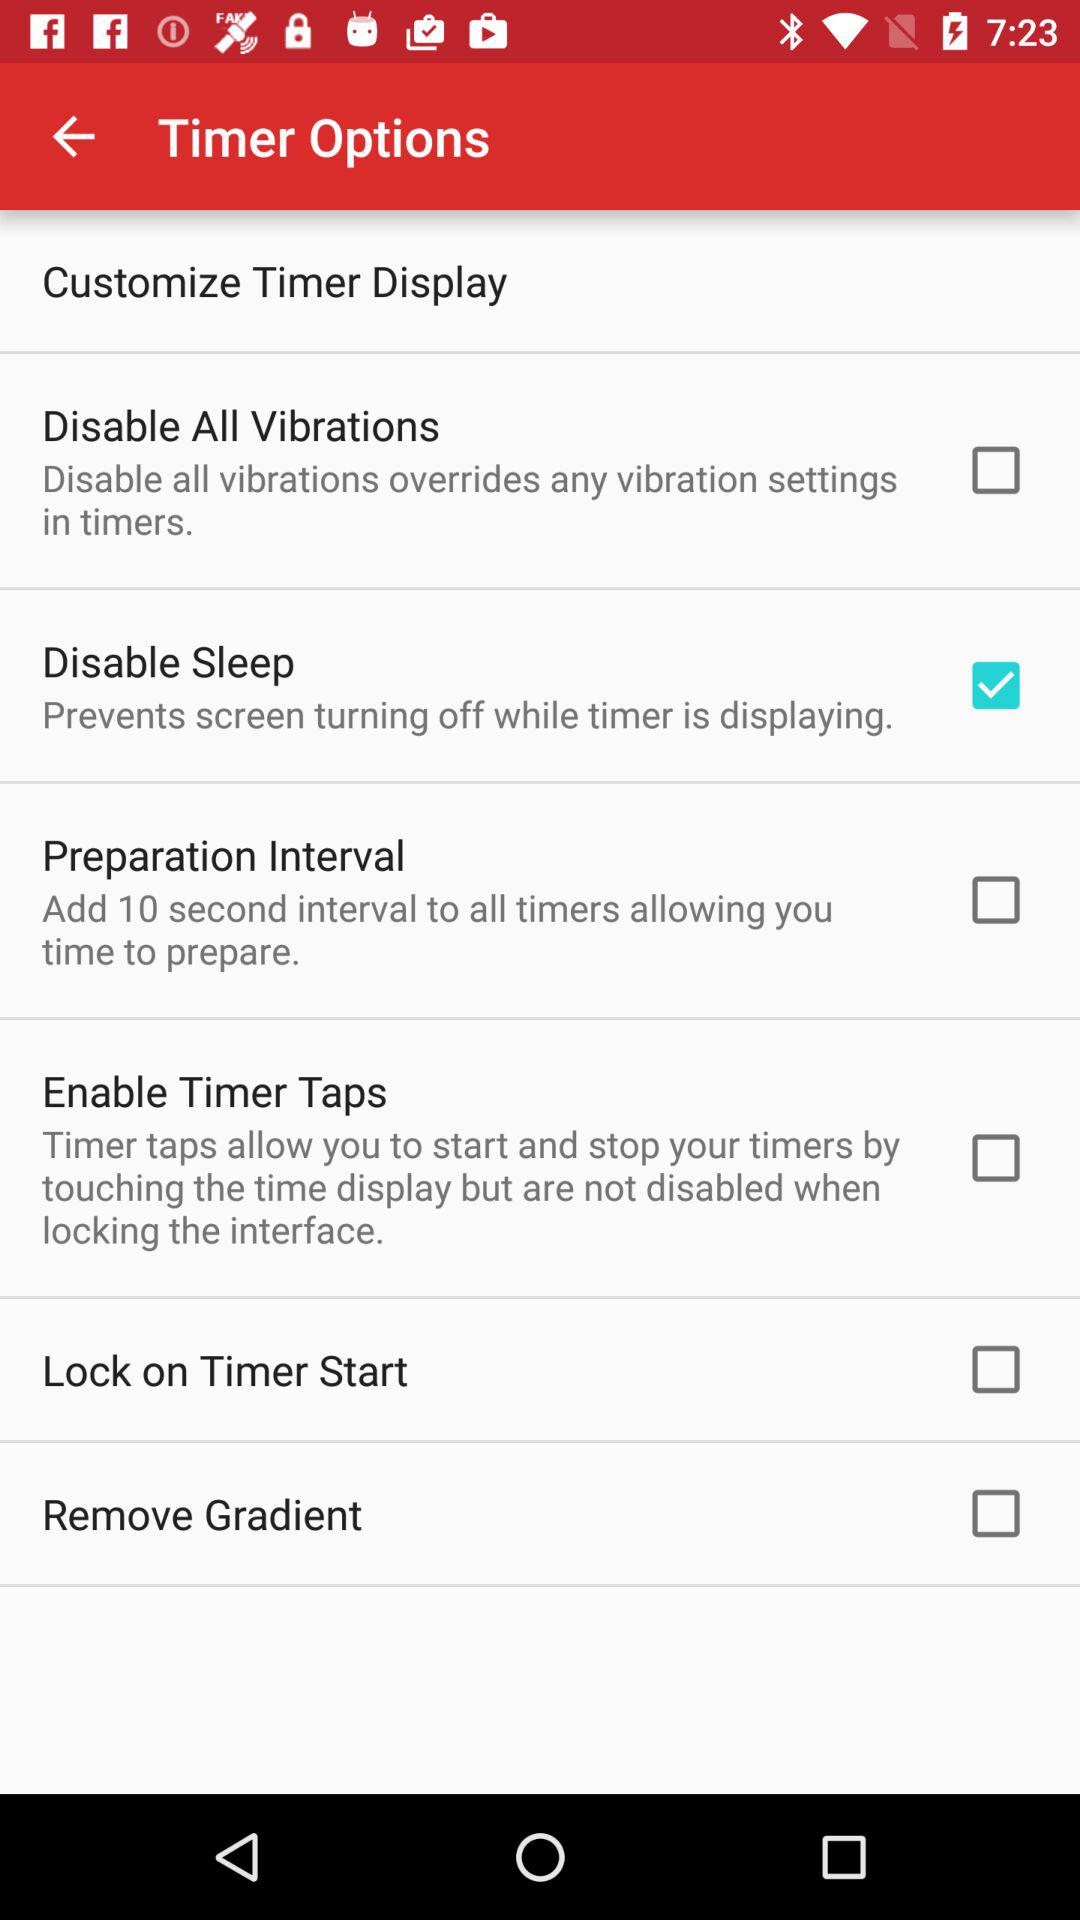How many options are there to customize the timer display?
Answer the question using a single word or phrase. 6 